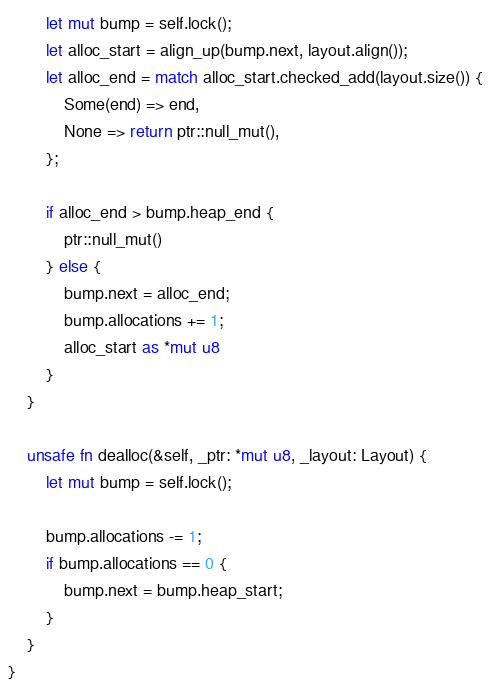<code> <loc_0><loc_0><loc_500><loc_500><_Rust_>        let mut bump = self.lock();
        let alloc_start = align_up(bump.next, layout.align());
        let alloc_end = match alloc_start.checked_add(layout.size()) {
            Some(end) => end,
            None => return ptr::null_mut(),
        };

        if alloc_end > bump.heap_end {
            ptr::null_mut()
        } else {
            bump.next = alloc_end;
            bump.allocations += 1;
            alloc_start as *mut u8
        }
    }

    unsafe fn dealloc(&self, _ptr: *mut u8, _layout: Layout) {
        let mut bump = self.lock();

        bump.allocations -= 1;
        if bump.allocations == 0 {
            bump.next = bump.heap_start;
        }
    }
}</code> 